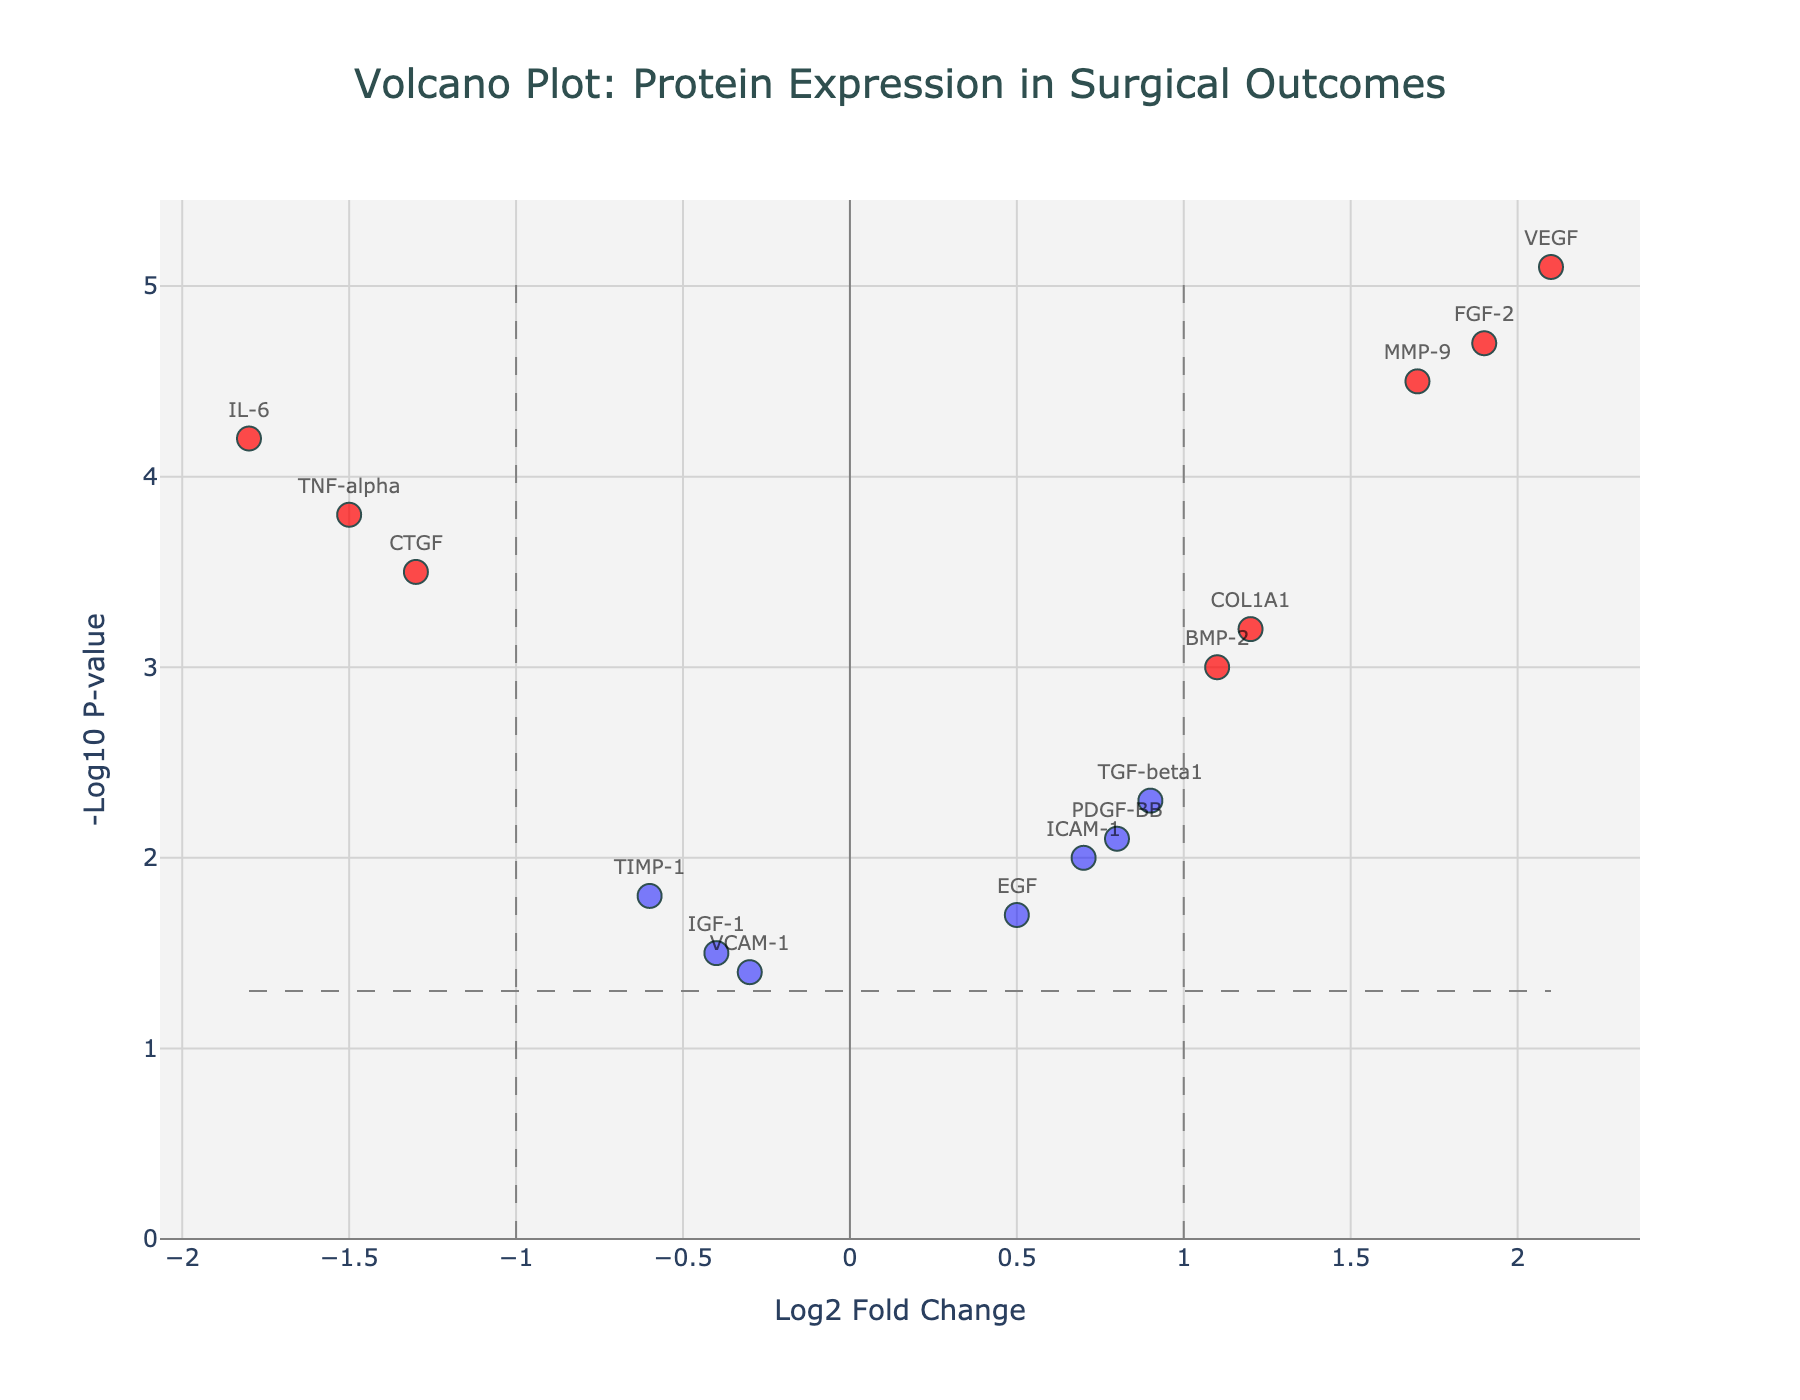How many data points are above the horizontal threshold line? The horizontal threshold line corresponds to a -Log10 p-value of -log10(0.05), which is approximately 1.3. We need to count how many data points are above this line.
Answer: 10 What is the highest -Log10 p-value in the plot, and which protein does it correspond to? By checking the y-axis values, the highest -Log10 p-value is 5.1, corresponding to the protein VEGF.
Answer: 5.1, VEGF Which protein has the greatest positive Log2 Fold Change? Checking the x-axis for the highest positive value, the greatest positive Log2 Fold Change is 2.1 for the protein VEGF.
Answer: VEGF Which proteins are significantly downregulated according to the plot? Proteins with a Log2 Fold Change less than -1 and a -Log10 p-value greater than 1.3 are considered significantly downregulated. These include IL-6 and TNF-alpha.
Answer: IL-6, TNF-alpha Compare the Log2 Fold Change values of MMP-9 and COL1A1. Which one is higher, and by how much? MMP-9 has a Log2 Fold Change of 1.7, and COL1A1 has a Log2 Fold Change of 1.2. The difference is 1.7 - 1.2 = 0.5.
Answer: MMP-9, 0.5 Are there more proteins upregulated or downregulated considered significant in the plot? Significant proteins have both a Log2 Fold Change greater than 1 (upregulated) or less than -1 (downregulated) and a -Log10 p-value greater than 1.3. We count the number of such proteins in each category.
Answer: More upregulated Which proteins are found close to the origin (0,0)? Close to the origin means small values for both Log2 Fold Change and -Log10 p-value. Proteins within a visual margin around the origin include VCAM-1 and IGF-1.
Answer: VCAM-1, IGF-1 